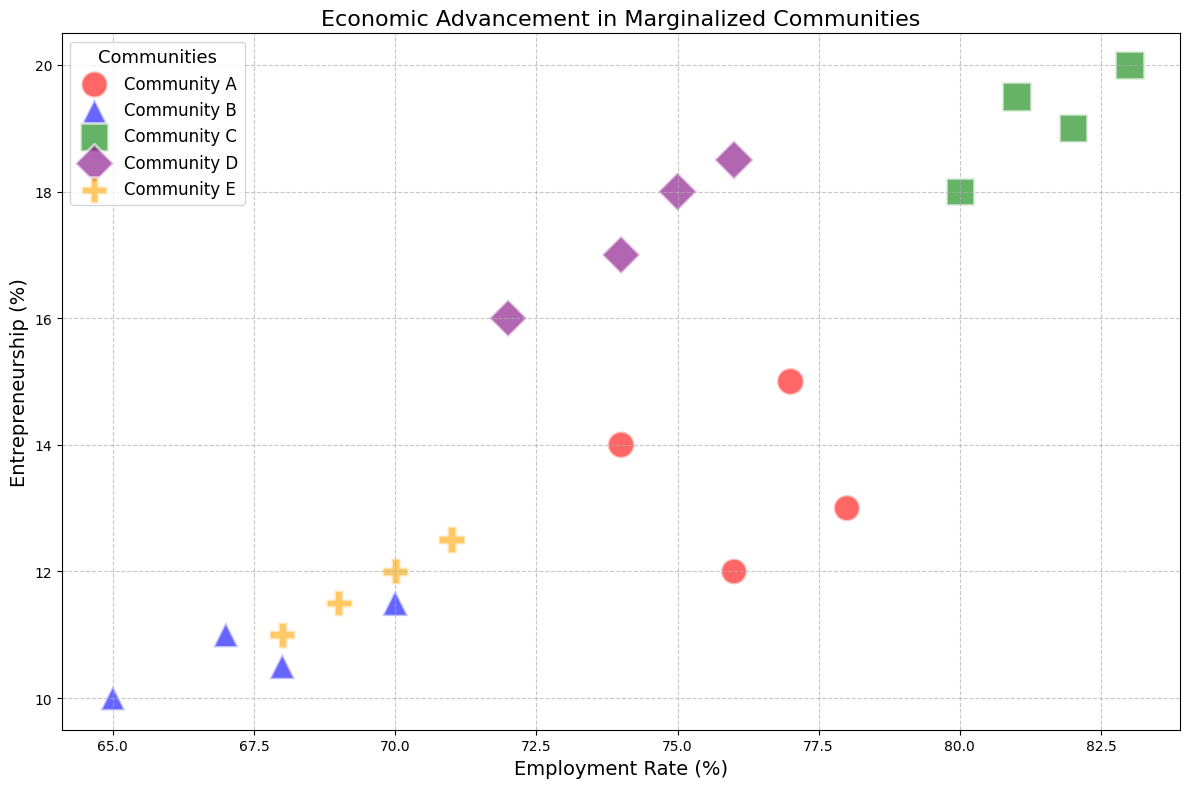Which community has the highest Entrepreneurship rate in 2021? To find this, look for the bubble with the highest y-value in 2021. Community C has the highest y-value at 20%.
Answer: Community C What is the average Employment Rate across all communities in 2021? Sum the employment rates for each community in 2021 (77 + 70 + 83 + 76 + 71), then divide by the number of communities (5). That is (77 + 70 + 83 + 76 + 71) / 5 = 377 / 5 = 75.4%.
Answer: 75.4% Which community has the lowest Average Income in 2018? Locate the smallest bubble size in the 2018 subset. Community B has the smallest bubble, indicating an average income of $32,000.
Answer: Community B Compare the change in Entrepreneurship between 2018 and 2021 for Community D and Community E. Which community experienced a higher change? For Community D, the change is 18.5 - 16 = 2.5%. For Community E, the change is 12.5 - 11 = 1.5%. Community D experienced a higher change (2.5% vs. 1.5%).
Answer: Community D Does Community A or Community B have a higher Employment Rate in 2020? Observe the bubbles' x-positions for the comparison. Community A has an employment rate of 74%, while Community B has 68%. Therefore, Community A has a higher rate.
Answer: Community A For which year is the Entrepreneurship rate approximately equal for Communities D and E? Search for the year where the y-values (Entrepreneurship rates) of Communities D and E are closest. In 2018, D's rate is 16%, E's is 11%; in 2019, D's is 17%, E's is 12%; in 2020, D's is 18%, E's is 11.5%; in 2021, D's is 18.5%, E's is 12.5%. The closest is in 2021 (18.5% vs 12.5%).
Answer: 2021 What is the total Entrepreneurship rate for all communities in 2019? Sum up the Entrepreneurship rates for all communities in 2019. That is 13 + 11 + 19 + 17 + 12 = 72%.
Answer: 72% Which community shows a consistent increase in Employment Rate from 2018 to 2021? Examine the x-value increases for each year. Community C consistently increases: 80% in 2018, 82% in 2019, 81% in 2020, and 83% in 2021.
Answer: Community C Is the Average Income in Community E in 2021 higher or lower than that in Community A in 2020? Compare bubble sizes for the two data points. Community E in 2021 has $37,000, and Community A in 2020 has $37,000. Thus, the incomes are equal.
Answer: Equal 